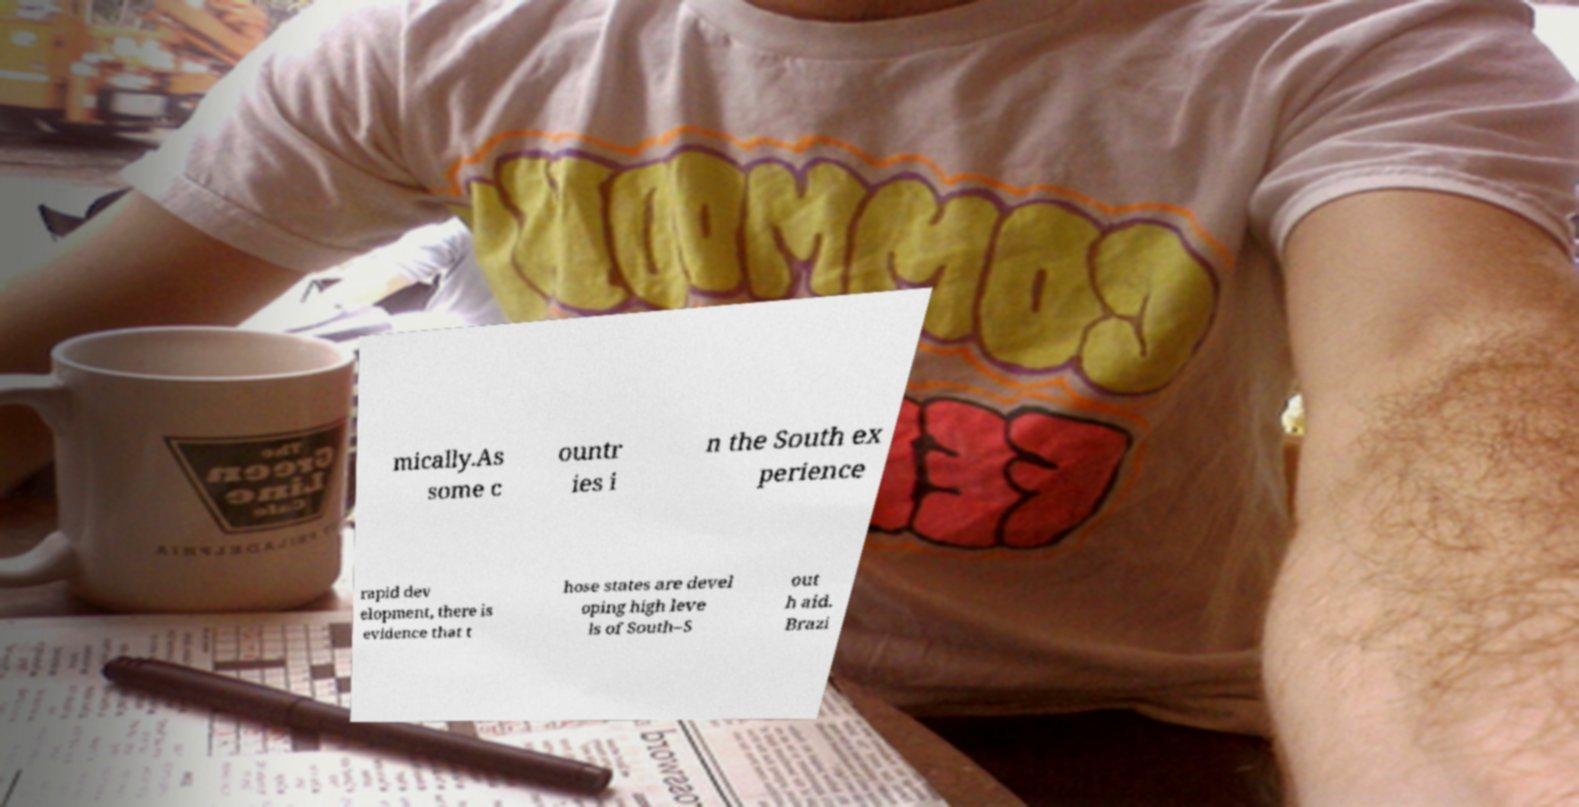Please read and relay the text visible in this image. What does it say? mically.As some c ountr ies i n the South ex perience rapid dev elopment, there is evidence that t hose states are devel oping high leve ls of South–S out h aid. Brazi 